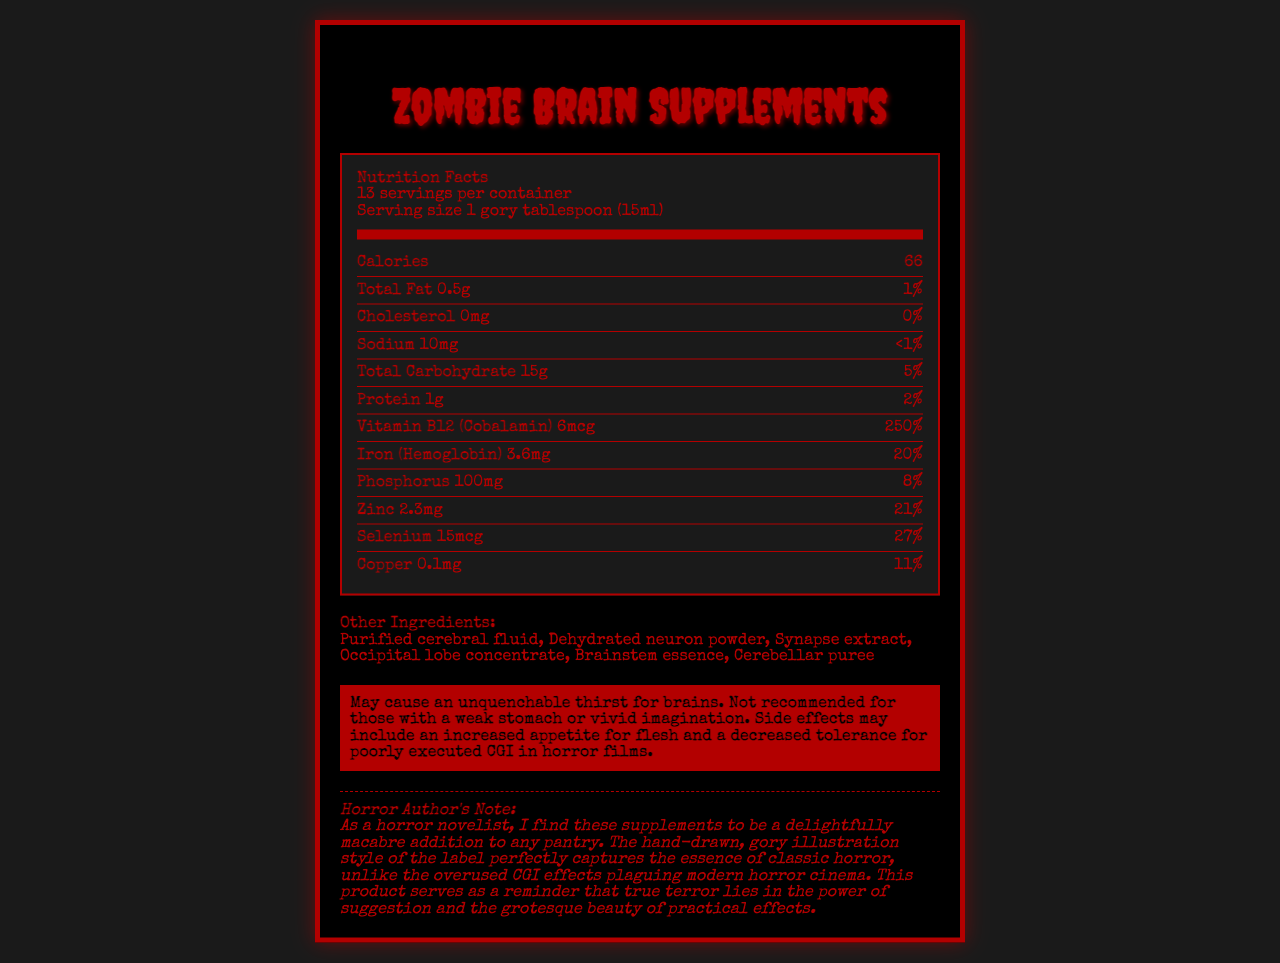Who is the product for, and what are the serving size and servings per container? The detailed information in the center of the nutrition label mentions both the serving size and the number of servings per container.
Answer: This product is intended for individuals seeking a macabre addition to their pantry. The serving size is 1 gory tablespoon (15ml), and there are 13 servings per container. What is the main idea conveyed in the Horror Author's Note? The Horror Author's Note explicitly praises the product's macabre nature and criticizes modern horror cinema's reliance on CGI, favoring practical effects.
Answer: The supplements are delightfully macabre, and the label's illustration style captures classic horror essence better than modern CGI effects. How many calories are there per serving? The nutrition label section lists the calorie content clearly as 66 per serving.
Answer: 66 calories Which vitamin or mineral has the highest daily value percentage? The document lists the daily value percentages of various vitamins and minerals, with Vitamin B12 (Cobalamin) having the highest at 250%.
Answer: Vitamin B12 (Cobalamin) with 250% daily value Are there any potential side effects mentioned? The warning section at the bottom includes potential side effects like unquenchable thirst for brains and an increased appetite for flesh.
Answer: Yes What is the total carbohydrate content and its daily value percentage? The total carbohydrate content and daily value are listed in the nutrition label section as 15g and 5%, respectively.
Answer: 15g, 5% Which of the following minerals has a daily value percentage under 10%? A. Zinc B. Iron C. Phosphorus D. Selenium E. Copper The document lists Phosphorus with an 8% daily value, which is the only one under 10% compared to the others listed.
Answer: C. Phosphorus Which ingredient seems most likely to cause a visceral reaction, based on the name? A. Synapse extract B. Dehydrated neuron powder C. Brainstem essence D. Cerebellar puree E. Occipital lobe concentrate All options are gory, but "Cerebellar puree" has a particularly graphic and visceral connotation.
Answer: D. Cerebellar puree True or False: The product has a high cholesterol content. The nutrition label clearly states that the cholesterol content is 0mg.
Answer: False Summarize the entire document. The document comprehensively combines nutrition facts, ingredients, a warning, a note from a horror author, and a visual description, presenting it in a dark, horror-themed style.
Answer: The document is a Nutrition Facts Label for "Zombie Brain Supplements" that presents the product’s nutritional information, including calories, fat, cholesterol, sodium, carbohydrates, protein, and various vitamins and minerals. It lists other ingredients with gory names and includes a warning about potential side effects. A Horror Author's Note praises the product's hand-drawn, gory illustration style and criticizes modern CGI effects in horror films. The visual description details the disturbing and meticulously drawn brain illustration on the label. What are the other ingredients in the product? The section labeled "Other Ingredients" lists these components.
Answer: Purified cerebral fluid, Dehydrated neuron powder, Synapse extract, Occipital lobe concentrate, Brainstem essence, Cerebellar puree Which vitamin or mineral has the lowest daily value percentage? Among the vitamins and minerals listed, Phosphorus has the lowest daily value percentage at 8%.
Answer: Phosphorus with 8% What is the protein content and its daily value percentage? The nutrition label shows the protein content as 1g with a 2% daily value.
Answer: 1g, 2% What can be inferred about the author's opinion on the use of CGI in horror films? The Horror Author's Note explicitly criticizes CGI in modern horror films and praises practical effects.
Answer: The author prefers practical effects over CGI, believing true terror lies in suggestion and practical effects. Who created the code to generate the document? The details of who created the code are not included in the document.
Answer: Cannot be determined 